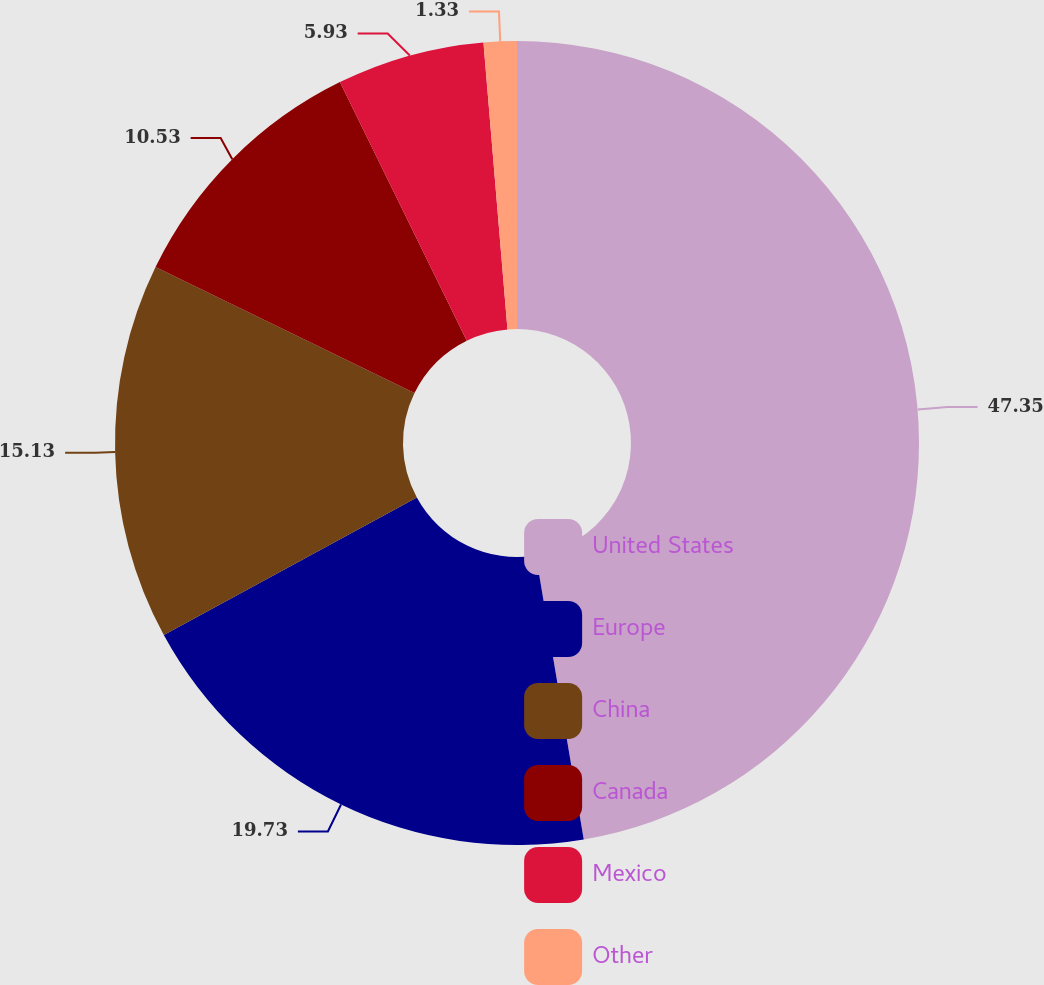<chart> <loc_0><loc_0><loc_500><loc_500><pie_chart><fcel>United States<fcel>Europe<fcel>China<fcel>Canada<fcel>Mexico<fcel>Other<nl><fcel>47.34%<fcel>19.73%<fcel>15.13%<fcel>10.53%<fcel>5.93%<fcel>1.33%<nl></chart> 